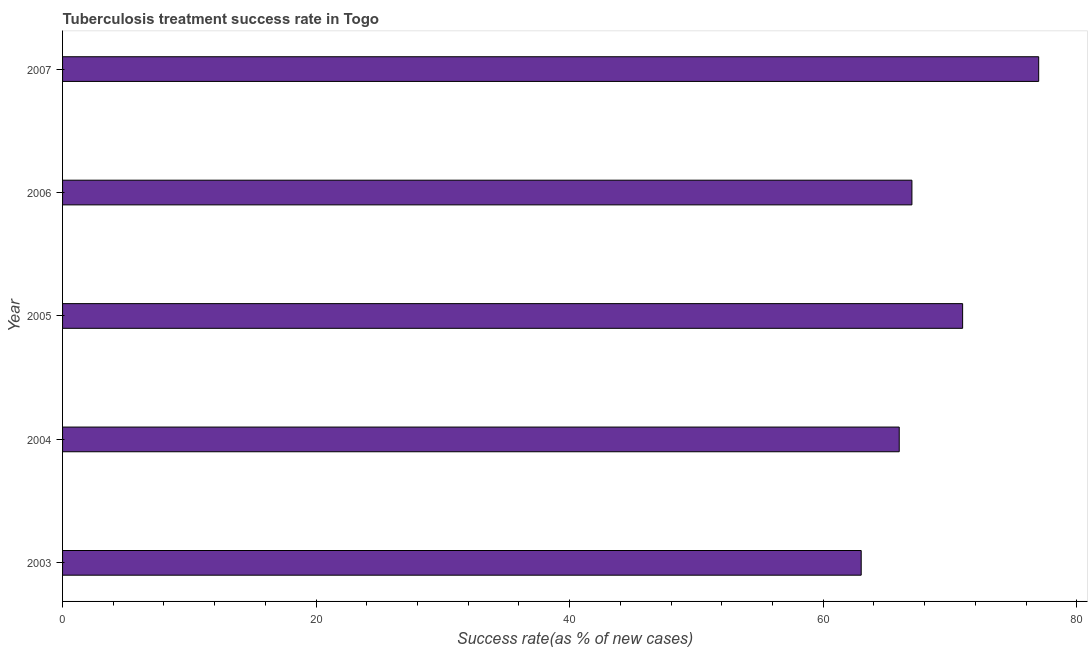Does the graph contain grids?
Offer a very short reply. No. What is the title of the graph?
Offer a very short reply. Tuberculosis treatment success rate in Togo. What is the label or title of the X-axis?
Your answer should be compact. Success rate(as % of new cases). What is the label or title of the Y-axis?
Provide a short and direct response. Year. Across all years, what is the maximum tuberculosis treatment success rate?
Make the answer very short. 77. In which year was the tuberculosis treatment success rate minimum?
Make the answer very short. 2003. What is the sum of the tuberculosis treatment success rate?
Make the answer very short. 344. What is the difference between the tuberculosis treatment success rate in 2003 and 2004?
Your answer should be compact. -3. Do a majority of the years between 2004 and 2005 (inclusive) have tuberculosis treatment success rate greater than 8 %?
Keep it short and to the point. Yes. What is the ratio of the tuberculosis treatment success rate in 2004 to that in 2006?
Offer a terse response. 0.98. Is the tuberculosis treatment success rate in 2003 less than that in 2006?
Ensure brevity in your answer.  Yes. Is the difference between the tuberculosis treatment success rate in 2004 and 2006 greater than the difference between any two years?
Provide a succinct answer. No. Is the sum of the tuberculosis treatment success rate in 2003 and 2007 greater than the maximum tuberculosis treatment success rate across all years?
Ensure brevity in your answer.  Yes. In how many years, is the tuberculosis treatment success rate greater than the average tuberculosis treatment success rate taken over all years?
Give a very brief answer. 2. What is the Success rate(as % of new cases) in 2005?
Provide a short and direct response. 71. What is the Success rate(as % of new cases) of 2006?
Keep it short and to the point. 67. What is the difference between the Success rate(as % of new cases) in 2003 and 2005?
Offer a terse response. -8. What is the difference between the Success rate(as % of new cases) in 2003 and 2006?
Provide a short and direct response. -4. What is the difference between the Success rate(as % of new cases) in 2004 and 2005?
Make the answer very short. -5. What is the difference between the Success rate(as % of new cases) in 2004 and 2006?
Keep it short and to the point. -1. What is the difference between the Success rate(as % of new cases) in 2005 and 2006?
Ensure brevity in your answer.  4. What is the difference between the Success rate(as % of new cases) in 2006 and 2007?
Give a very brief answer. -10. What is the ratio of the Success rate(as % of new cases) in 2003 to that in 2004?
Ensure brevity in your answer.  0.95. What is the ratio of the Success rate(as % of new cases) in 2003 to that in 2005?
Ensure brevity in your answer.  0.89. What is the ratio of the Success rate(as % of new cases) in 2003 to that in 2007?
Ensure brevity in your answer.  0.82. What is the ratio of the Success rate(as % of new cases) in 2004 to that in 2005?
Ensure brevity in your answer.  0.93. What is the ratio of the Success rate(as % of new cases) in 2004 to that in 2007?
Ensure brevity in your answer.  0.86. What is the ratio of the Success rate(as % of new cases) in 2005 to that in 2006?
Give a very brief answer. 1.06. What is the ratio of the Success rate(as % of new cases) in 2005 to that in 2007?
Keep it short and to the point. 0.92. What is the ratio of the Success rate(as % of new cases) in 2006 to that in 2007?
Your response must be concise. 0.87. 